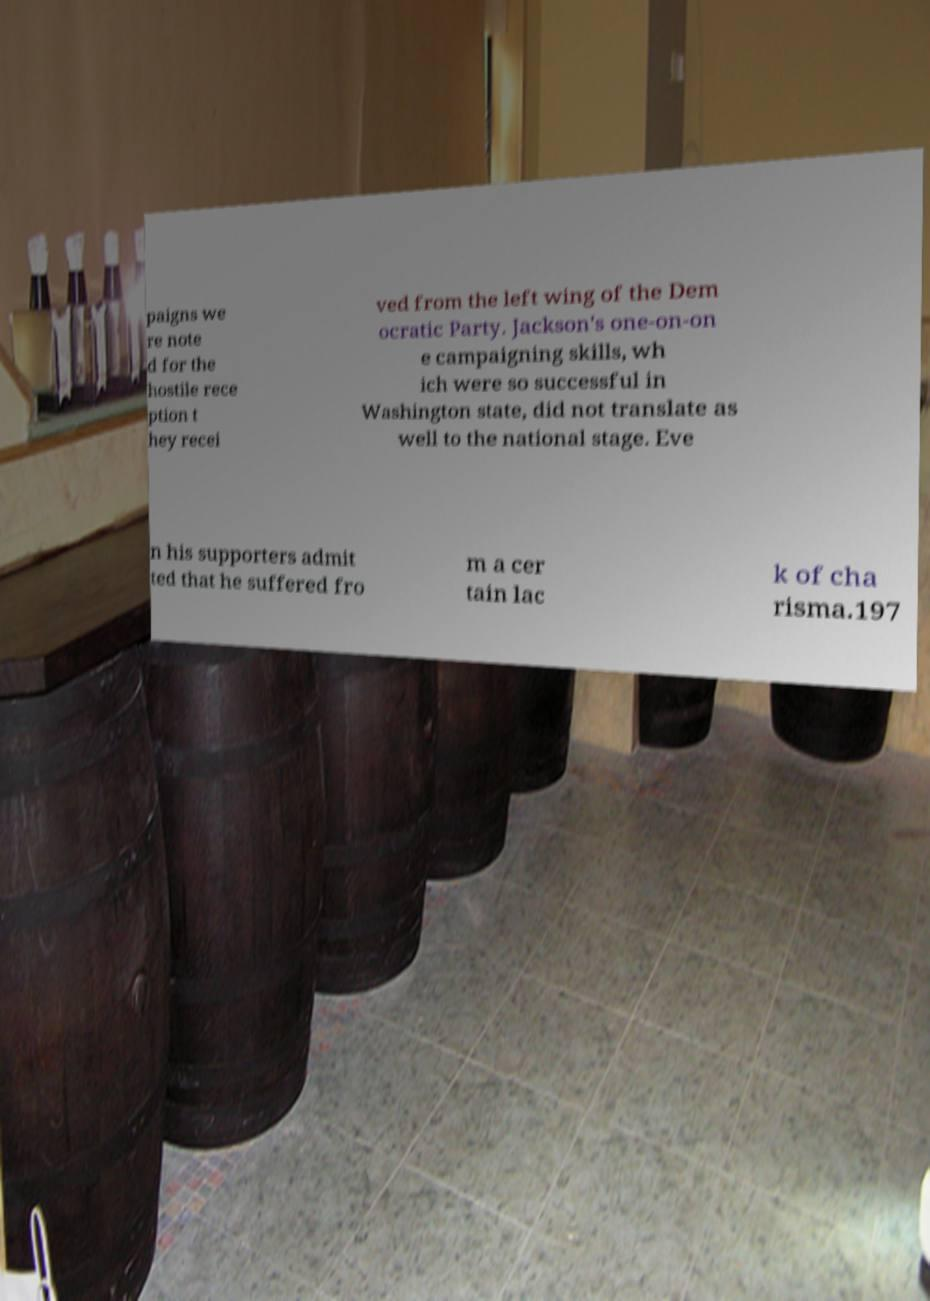Could you extract and type out the text from this image? paigns we re note d for the hostile rece ption t hey recei ved from the left wing of the Dem ocratic Party. Jackson's one-on-on e campaigning skills, wh ich were so successful in Washington state, did not translate as well to the national stage. Eve n his supporters admit ted that he suffered fro m a cer tain lac k of cha risma.197 